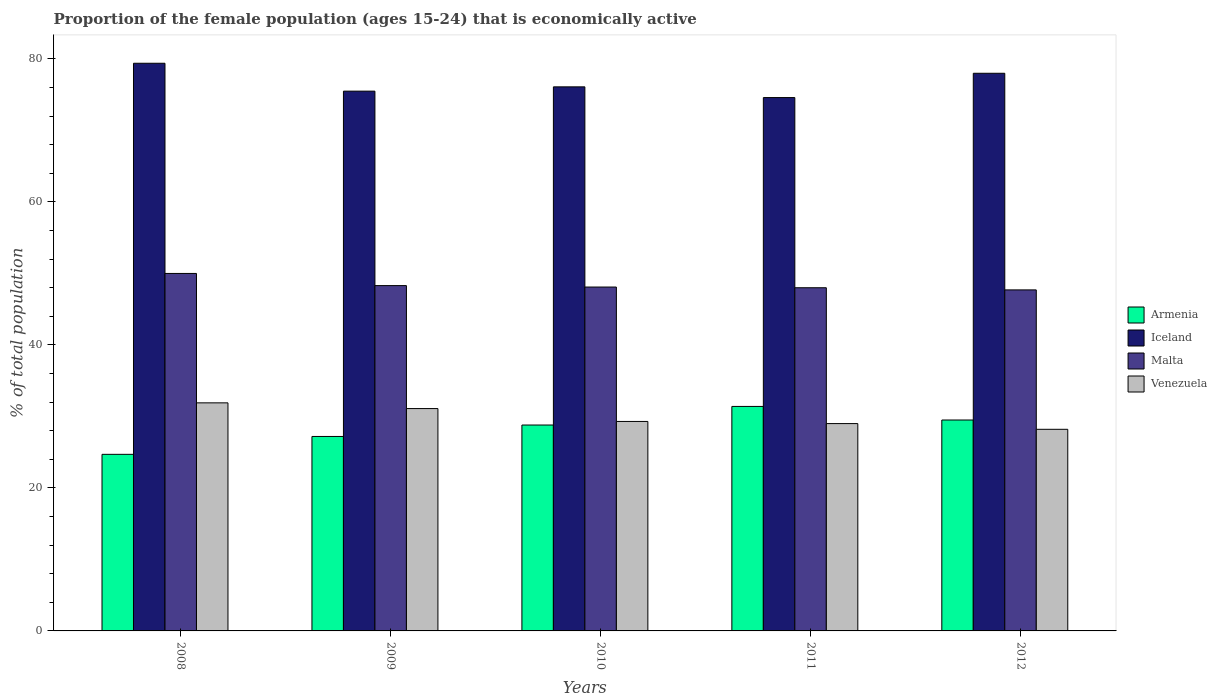How many different coloured bars are there?
Offer a terse response. 4. How many groups of bars are there?
Your response must be concise. 5. Are the number of bars per tick equal to the number of legend labels?
Your answer should be very brief. Yes. How many bars are there on the 4th tick from the right?
Your answer should be compact. 4. What is the proportion of the female population that is economically active in Iceland in 2011?
Ensure brevity in your answer.  74.6. Across all years, what is the maximum proportion of the female population that is economically active in Iceland?
Offer a terse response. 79.4. Across all years, what is the minimum proportion of the female population that is economically active in Armenia?
Keep it short and to the point. 24.7. In which year was the proportion of the female population that is economically active in Armenia maximum?
Offer a very short reply. 2011. What is the total proportion of the female population that is economically active in Iceland in the graph?
Make the answer very short. 383.6. What is the difference between the proportion of the female population that is economically active in Armenia in 2011 and that in 2012?
Offer a very short reply. 1.9. What is the difference between the proportion of the female population that is economically active in Iceland in 2011 and the proportion of the female population that is economically active in Venezuela in 2010?
Your response must be concise. 45.3. What is the average proportion of the female population that is economically active in Armenia per year?
Offer a terse response. 28.32. In the year 2011, what is the difference between the proportion of the female population that is economically active in Iceland and proportion of the female population that is economically active in Armenia?
Keep it short and to the point. 43.2. What is the ratio of the proportion of the female population that is economically active in Venezuela in 2008 to that in 2009?
Provide a short and direct response. 1.03. Is the proportion of the female population that is economically active in Venezuela in 2008 less than that in 2011?
Provide a short and direct response. No. Is the difference between the proportion of the female population that is economically active in Iceland in 2008 and 2010 greater than the difference between the proportion of the female population that is economically active in Armenia in 2008 and 2010?
Offer a terse response. Yes. What is the difference between the highest and the second highest proportion of the female population that is economically active in Venezuela?
Keep it short and to the point. 0.8. What is the difference between the highest and the lowest proportion of the female population that is economically active in Armenia?
Your answer should be very brief. 6.7. Is the sum of the proportion of the female population that is economically active in Iceland in 2008 and 2010 greater than the maximum proportion of the female population that is economically active in Malta across all years?
Your answer should be very brief. Yes. Is it the case that in every year, the sum of the proportion of the female population that is economically active in Venezuela and proportion of the female population that is economically active in Armenia is greater than the sum of proportion of the female population that is economically active in Malta and proportion of the female population that is economically active in Iceland?
Offer a terse response. Yes. What does the 3rd bar from the left in 2009 represents?
Ensure brevity in your answer.  Malta. Is it the case that in every year, the sum of the proportion of the female population that is economically active in Iceland and proportion of the female population that is economically active in Venezuela is greater than the proportion of the female population that is economically active in Malta?
Provide a succinct answer. Yes. Are all the bars in the graph horizontal?
Provide a short and direct response. No. Are the values on the major ticks of Y-axis written in scientific E-notation?
Make the answer very short. No. Does the graph contain any zero values?
Ensure brevity in your answer.  No. Where does the legend appear in the graph?
Your response must be concise. Center right. What is the title of the graph?
Give a very brief answer. Proportion of the female population (ages 15-24) that is economically active. What is the label or title of the Y-axis?
Give a very brief answer. % of total population. What is the % of total population of Armenia in 2008?
Keep it short and to the point. 24.7. What is the % of total population in Iceland in 2008?
Offer a very short reply. 79.4. What is the % of total population in Venezuela in 2008?
Provide a succinct answer. 31.9. What is the % of total population of Armenia in 2009?
Make the answer very short. 27.2. What is the % of total population of Iceland in 2009?
Ensure brevity in your answer.  75.5. What is the % of total population of Malta in 2009?
Your response must be concise. 48.3. What is the % of total population in Venezuela in 2009?
Your answer should be compact. 31.1. What is the % of total population in Armenia in 2010?
Offer a terse response. 28.8. What is the % of total population in Iceland in 2010?
Make the answer very short. 76.1. What is the % of total population in Malta in 2010?
Ensure brevity in your answer.  48.1. What is the % of total population in Venezuela in 2010?
Your response must be concise. 29.3. What is the % of total population in Armenia in 2011?
Your answer should be compact. 31.4. What is the % of total population of Iceland in 2011?
Offer a terse response. 74.6. What is the % of total population in Malta in 2011?
Offer a terse response. 48. What is the % of total population in Armenia in 2012?
Your answer should be compact. 29.5. What is the % of total population of Iceland in 2012?
Make the answer very short. 78. What is the % of total population of Malta in 2012?
Provide a succinct answer. 47.7. What is the % of total population of Venezuela in 2012?
Offer a terse response. 28.2. Across all years, what is the maximum % of total population of Armenia?
Ensure brevity in your answer.  31.4. Across all years, what is the maximum % of total population in Iceland?
Make the answer very short. 79.4. Across all years, what is the maximum % of total population of Malta?
Ensure brevity in your answer.  50. Across all years, what is the maximum % of total population of Venezuela?
Keep it short and to the point. 31.9. Across all years, what is the minimum % of total population of Armenia?
Give a very brief answer. 24.7. Across all years, what is the minimum % of total population in Iceland?
Give a very brief answer. 74.6. Across all years, what is the minimum % of total population in Malta?
Offer a very short reply. 47.7. Across all years, what is the minimum % of total population in Venezuela?
Offer a very short reply. 28.2. What is the total % of total population of Armenia in the graph?
Your answer should be very brief. 141.6. What is the total % of total population in Iceland in the graph?
Your answer should be very brief. 383.6. What is the total % of total population in Malta in the graph?
Your answer should be compact. 242.1. What is the total % of total population in Venezuela in the graph?
Your answer should be compact. 149.5. What is the difference between the % of total population of Iceland in 2008 and that in 2009?
Make the answer very short. 3.9. What is the difference between the % of total population in Iceland in 2008 and that in 2010?
Offer a very short reply. 3.3. What is the difference between the % of total population in Venezuela in 2008 and that in 2010?
Offer a terse response. 2.6. What is the difference between the % of total population in Iceland in 2008 and that in 2011?
Your response must be concise. 4.8. What is the difference between the % of total population of Malta in 2008 and that in 2011?
Make the answer very short. 2. What is the difference between the % of total population in Iceland in 2008 and that in 2012?
Provide a succinct answer. 1.4. What is the difference between the % of total population of Malta in 2008 and that in 2012?
Offer a terse response. 2.3. What is the difference between the % of total population of Venezuela in 2008 and that in 2012?
Your answer should be very brief. 3.7. What is the difference between the % of total population in Armenia in 2009 and that in 2010?
Give a very brief answer. -1.6. What is the difference between the % of total population of Malta in 2009 and that in 2010?
Offer a terse response. 0.2. What is the difference between the % of total population of Venezuela in 2009 and that in 2010?
Your response must be concise. 1.8. What is the difference between the % of total population of Malta in 2009 and that in 2011?
Ensure brevity in your answer.  0.3. What is the difference between the % of total population in Iceland in 2009 and that in 2012?
Your response must be concise. -2.5. What is the difference between the % of total population of Malta in 2009 and that in 2012?
Your answer should be very brief. 0.6. What is the difference between the % of total population in Venezuela in 2009 and that in 2012?
Your answer should be compact. 2.9. What is the difference between the % of total population of Malta in 2010 and that in 2011?
Your response must be concise. 0.1. What is the difference between the % of total population in Armenia in 2010 and that in 2012?
Provide a short and direct response. -0.7. What is the difference between the % of total population in Malta in 2010 and that in 2012?
Offer a terse response. 0.4. What is the difference between the % of total population in Venezuela in 2010 and that in 2012?
Your answer should be very brief. 1.1. What is the difference between the % of total population in Armenia in 2008 and the % of total population in Iceland in 2009?
Provide a short and direct response. -50.8. What is the difference between the % of total population in Armenia in 2008 and the % of total population in Malta in 2009?
Provide a short and direct response. -23.6. What is the difference between the % of total population in Armenia in 2008 and the % of total population in Venezuela in 2009?
Your answer should be compact. -6.4. What is the difference between the % of total population in Iceland in 2008 and the % of total population in Malta in 2009?
Ensure brevity in your answer.  31.1. What is the difference between the % of total population in Iceland in 2008 and the % of total population in Venezuela in 2009?
Your response must be concise. 48.3. What is the difference between the % of total population in Malta in 2008 and the % of total population in Venezuela in 2009?
Offer a terse response. 18.9. What is the difference between the % of total population of Armenia in 2008 and the % of total population of Iceland in 2010?
Your answer should be compact. -51.4. What is the difference between the % of total population in Armenia in 2008 and the % of total population in Malta in 2010?
Keep it short and to the point. -23.4. What is the difference between the % of total population of Armenia in 2008 and the % of total population of Venezuela in 2010?
Offer a terse response. -4.6. What is the difference between the % of total population of Iceland in 2008 and the % of total population of Malta in 2010?
Provide a succinct answer. 31.3. What is the difference between the % of total population of Iceland in 2008 and the % of total population of Venezuela in 2010?
Provide a succinct answer. 50.1. What is the difference between the % of total population in Malta in 2008 and the % of total population in Venezuela in 2010?
Your response must be concise. 20.7. What is the difference between the % of total population in Armenia in 2008 and the % of total population in Iceland in 2011?
Keep it short and to the point. -49.9. What is the difference between the % of total population in Armenia in 2008 and the % of total population in Malta in 2011?
Ensure brevity in your answer.  -23.3. What is the difference between the % of total population of Iceland in 2008 and the % of total population of Malta in 2011?
Your answer should be very brief. 31.4. What is the difference between the % of total population in Iceland in 2008 and the % of total population in Venezuela in 2011?
Keep it short and to the point. 50.4. What is the difference between the % of total population in Armenia in 2008 and the % of total population in Iceland in 2012?
Your answer should be very brief. -53.3. What is the difference between the % of total population in Iceland in 2008 and the % of total population in Malta in 2012?
Provide a succinct answer. 31.7. What is the difference between the % of total population of Iceland in 2008 and the % of total population of Venezuela in 2012?
Offer a terse response. 51.2. What is the difference between the % of total population in Malta in 2008 and the % of total population in Venezuela in 2012?
Your response must be concise. 21.8. What is the difference between the % of total population of Armenia in 2009 and the % of total population of Iceland in 2010?
Your response must be concise. -48.9. What is the difference between the % of total population in Armenia in 2009 and the % of total population in Malta in 2010?
Ensure brevity in your answer.  -20.9. What is the difference between the % of total population in Armenia in 2009 and the % of total population in Venezuela in 2010?
Offer a terse response. -2.1. What is the difference between the % of total population of Iceland in 2009 and the % of total population of Malta in 2010?
Make the answer very short. 27.4. What is the difference between the % of total population in Iceland in 2009 and the % of total population in Venezuela in 2010?
Your answer should be compact. 46.2. What is the difference between the % of total population in Malta in 2009 and the % of total population in Venezuela in 2010?
Keep it short and to the point. 19. What is the difference between the % of total population of Armenia in 2009 and the % of total population of Iceland in 2011?
Give a very brief answer. -47.4. What is the difference between the % of total population of Armenia in 2009 and the % of total population of Malta in 2011?
Provide a succinct answer. -20.8. What is the difference between the % of total population in Armenia in 2009 and the % of total population in Venezuela in 2011?
Offer a very short reply. -1.8. What is the difference between the % of total population in Iceland in 2009 and the % of total population in Malta in 2011?
Offer a terse response. 27.5. What is the difference between the % of total population of Iceland in 2009 and the % of total population of Venezuela in 2011?
Your response must be concise. 46.5. What is the difference between the % of total population of Malta in 2009 and the % of total population of Venezuela in 2011?
Your answer should be compact. 19.3. What is the difference between the % of total population of Armenia in 2009 and the % of total population of Iceland in 2012?
Offer a very short reply. -50.8. What is the difference between the % of total population of Armenia in 2009 and the % of total population of Malta in 2012?
Offer a very short reply. -20.5. What is the difference between the % of total population in Iceland in 2009 and the % of total population in Malta in 2012?
Your answer should be very brief. 27.8. What is the difference between the % of total population in Iceland in 2009 and the % of total population in Venezuela in 2012?
Offer a terse response. 47.3. What is the difference between the % of total population in Malta in 2009 and the % of total population in Venezuela in 2012?
Ensure brevity in your answer.  20.1. What is the difference between the % of total population in Armenia in 2010 and the % of total population in Iceland in 2011?
Offer a terse response. -45.8. What is the difference between the % of total population of Armenia in 2010 and the % of total population of Malta in 2011?
Give a very brief answer. -19.2. What is the difference between the % of total population of Iceland in 2010 and the % of total population of Malta in 2011?
Make the answer very short. 28.1. What is the difference between the % of total population in Iceland in 2010 and the % of total population in Venezuela in 2011?
Provide a succinct answer. 47.1. What is the difference between the % of total population in Armenia in 2010 and the % of total population in Iceland in 2012?
Your answer should be compact. -49.2. What is the difference between the % of total population of Armenia in 2010 and the % of total population of Malta in 2012?
Keep it short and to the point. -18.9. What is the difference between the % of total population of Armenia in 2010 and the % of total population of Venezuela in 2012?
Give a very brief answer. 0.6. What is the difference between the % of total population of Iceland in 2010 and the % of total population of Malta in 2012?
Provide a succinct answer. 28.4. What is the difference between the % of total population in Iceland in 2010 and the % of total population in Venezuela in 2012?
Make the answer very short. 47.9. What is the difference between the % of total population of Malta in 2010 and the % of total population of Venezuela in 2012?
Offer a very short reply. 19.9. What is the difference between the % of total population in Armenia in 2011 and the % of total population in Iceland in 2012?
Make the answer very short. -46.6. What is the difference between the % of total population of Armenia in 2011 and the % of total population of Malta in 2012?
Provide a succinct answer. -16.3. What is the difference between the % of total population of Armenia in 2011 and the % of total population of Venezuela in 2012?
Your answer should be compact. 3.2. What is the difference between the % of total population in Iceland in 2011 and the % of total population in Malta in 2012?
Offer a terse response. 26.9. What is the difference between the % of total population of Iceland in 2011 and the % of total population of Venezuela in 2012?
Your response must be concise. 46.4. What is the difference between the % of total population in Malta in 2011 and the % of total population in Venezuela in 2012?
Keep it short and to the point. 19.8. What is the average % of total population in Armenia per year?
Give a very brief answer. 28.32. What is the average % of total population of Iceland per year?
Your response must be concise. 76.72. What is the average % of total population of Malta per year?
Offer a very short reply. 48.42. What is the average % of total population in Venezuela per year?
Your answer should be very brief. 29.9. In the year 2008, what is the difference between the % of total population of Armenia and % of total population of Iceland?
Ensure brevity in your answer.  -54.7. In the year 2008, what is the difference between the % of total population of Armenia and % of total population of Malta?
Offer a terse response. -25.3. In the year 2008, what is the difference between the % of total population of Armenia and % of total population of Venezuela?
Offer a terse response. -7.2. In the year 2008, what is the difference between the % of total population in Iceland and % of total population in Malta?
Provide a short and direct response. 29.4. In the year 2008, what is the difference between the % of total population of Iceland and % of total population of Venezuela?
Provide a short and direct response. 47.5. In the year 2008, what is the difference between the % of total population in Malta and % of total population in Venezuela?
Make the answer very short. 18.1. In the year 2009, what is the difference between the % of total population in Armenia and % of total population in Iceland?
Offer a very short reply. -48.3. In the year 2009, what is the difference between the % of total population of Armenia and % of total population of Malta?
Ensure brevity in your answer.  -21.1. In the year 2009, what is the difference between the % of total population of Iceland and % of total population of Malta?
Provide a succinct answer. 27.2. In the year 2009, what is the difference between the % of total population of Iceland and % of total population of Venezuela?
Keep it short and to the point. 44.4. In the year 2010, what is the difference between the % of total population in Armenia and % of total population in Iceland?
Your response must be concise. -47.3. In the year 2010, what is the difference between the % of total population in Armenia and % of total population in Malta?
Keep it short and to the point. -19.3. In the year 2010, what is the difference between the % of total population of Iceland and % of total population of Malta?
Offer a very short reply. 28. In the year 2010, what is the difference between the % of total population in Iceland and % of total population in Venezuela?
Make the answer very short. 46.8. In the year 2010, what is the difference between the % of total population in Malta and % of total population in Venezuela?
Provide a short and direct response. 18.8. In the year 2011, what is the difference between the % of total population of Armenia and % of total population of Iceland?
Keep it short and to the point. -43.2. In the year 2011, what is the difference between the % of total population in Armenia and % of total population in Malta?
Provide a short and direct response. -16.6. In the year 2011, what is the difference between the % of total population of Armenia and % of total population of Venezuela?
Offer a very short reply. 2.4. In the year 2011, what is the difference between the % of total population of Iceland and % of total population of Malta?
Your answer should be compact. 26.6. In the year 2011, what is the difference between the % of total population in Iceland and % of total population in Venezuela?
Provide a short and direct response. 45.6. In the year 2012, what is the difference between the % of total population of Armenia and % of total population of Iceland?
Ensure brevity in your answer.  -48.5. In the year 2012, what is the difference between the % of total population of Armenia and % of total population of Malta?
Provide a short and direct response. -18.2. In the year 2012, what is the difference between the % of total population of Iceland and % of total population of Malta?
Offer a very short reply. 30.3. In the year 2012, what is the difference between the % of total population of Iceland and % of total population of Venezuela?
Provide a short and direct response. 49.8. What is the ratio of the % of total population in Armenia in 2008 to that in 2009?
Provide a succinct answer. 0.91. What is the ratio of the % of total population of Iceland in 2008 to that in 2009?
Your response must be concise. 1.05. What is the ratio of the % of total population in Malta in 2008 to that in 2009?
Your answer should be very brief. 1.04. What is the ratio of the % of total population in Venezuela in 2008 to that in 2009?
Your answer should be very brief. 1.03. What is the ratio of the % of total population in Armenia in 2008 to that in 2010?
Provide a short and direct response. 0.86. What is the ratio of the % of total population in Iceland in 2008 to that in 2010?
Your response must be concise. 1.04. What is the ratio of the % of total population of Malta in 2008 to that in 2010?
Provide a succinct answer. 1.04. What is the ratio of the % of total population in Venezuela in 2008 to that in 2010?
Give a very brief answer. 1.09. What is the ratio of the % of total population in Armenia in 2008 to that in 2011?
Make the answer very short. 0.79. What is the ratio of the % of total population in Iceland in 2008 to that in 2011?
Make the answer very short. 1.06. What is the ratio of the % of total population in Malta in 2008 to that in 2011?
Make the answer very short. 1.04. What is the ratio of the % of total population in Armenia in 2008 to that in 2012?
Offer a very short reply. 0.84. What is the ratio of the % of total population of Iceland in 2008 to that in 2012?
Your answer should be very brief. 1.02. What is the ratio of the % of total population in Malta in 2008 to that in 2012?
Your answer should be very brief. 1.05. What is the ratio of the % of total population of Venezuela in 2008 to that in 2012?
Give a very brief answer. 1.13. What is the ratio of the % of total population in Malta in 2009 to that in 2010?
Keep it short and to the point. 1. What is the ratio of the % of total population in Venezuela in 2009 to that in 2010?
Your response must be concise. 1.06. What is the ratio of the % of total population in Armenia in 2009 to that in 2011?
Ensure brevity in your answer.  0.87. What is the ratio of the % of total population of Iceland in 2009 to that in 2011?
Your response must be concise. 1.01. What is the ratio of the % of total population of Venezuela in 2009 to that in 2011?
Offer a very short reply. 1.07. What is the ratio of the % of total population in Armenia in 2009 to that in 2012?
Make the answer very short. 0.92. What is the ratio of the % of total population of Iceland in 2009 to that in 2012?
Keep it short and to the point. 0.97. What is the ratio of the % of total population of Malta in 2009 to that in 2012?
Your answer should be very brief. 1.01. What is the ratio of the % of total population in Venezuela in 2009 to that in 2012?
Your response must be concise. 1.1. What is the ratio of the % of total population in Armenia in 2010 to that in 2011?
Make the answer very short. 0.92. What is the ratio of the % of total population in Iceland in 2010 to that in 2011?
Provide a succinct answer. 1.02. What is the ratio of the % of total population in Venezuela in 2010 to that in 2011?
Offer a terse response. 1.01. What is the ratio of the % of total population of Armenia in 2010 to that in 2012?
Give a very brief answer. 0.98. What is the ratio of the % of total population of Iceland in 2010 to that in 2012?
Ensure brevity in your answer.  0.98. What is the ratio of the % of total population of Malta in 2010 to that in 2012?
Offer a very short reply. 1.01. What is the ratio of the % of total population of Venezuela in 2010 to that in 2012?
Provide a succinct answer. 1.04. What is the ratio of the % of total population in Armenia in 2011 to that in 2012?
Your answer should be compact. 1.06. What is the ratio of the % of total population in Iceland in 2011 to that in 2012?
Make the answer very short. 0.96. What is the ratio of the % of total population of Malta in 2011 to that in 2012?
Give a very brief answer. 1.01. What is the ratio of the % of total population in Venezuela in 2011 to that in 2012?
Ensure brevity in your answer.  1.03. What is the difference between the highest and the lowest % of total population of Armenia?
Your answer should be very brief. 6.7. What is the difference between the highest and the lowest % of total population in Iceland?
Your response must be concise. 4.8. What is the difference between the highest and the lowest % of total population of Malta?
Provide a short and direct response. 2.3. What is the difference between the highest and the lowest % of total population in Venezuela?
Make the answer very short. 3.7. 